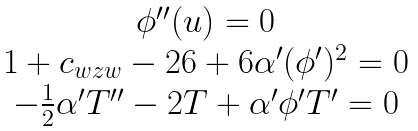<formula> <loc_0><loc_0><loc_500><loc_500>\begin{array} { c } \phi ^ { \prime \prime } ( u ) = 0 \\ 1 + c _ { w z w } - 2 6 + 6 \alpha ^ { \prime } ( \phi ^ { \prime } ) ^ { 2 } = 0 \\ - \frac { 1 } { 2 } \alpha ^ { \prime } T ^ { \prime \prime } - 2 T + \alpha ^ { \prime } \phi ^ { \prime } T ^ { \prime } = 0 \end{array}</formula> 